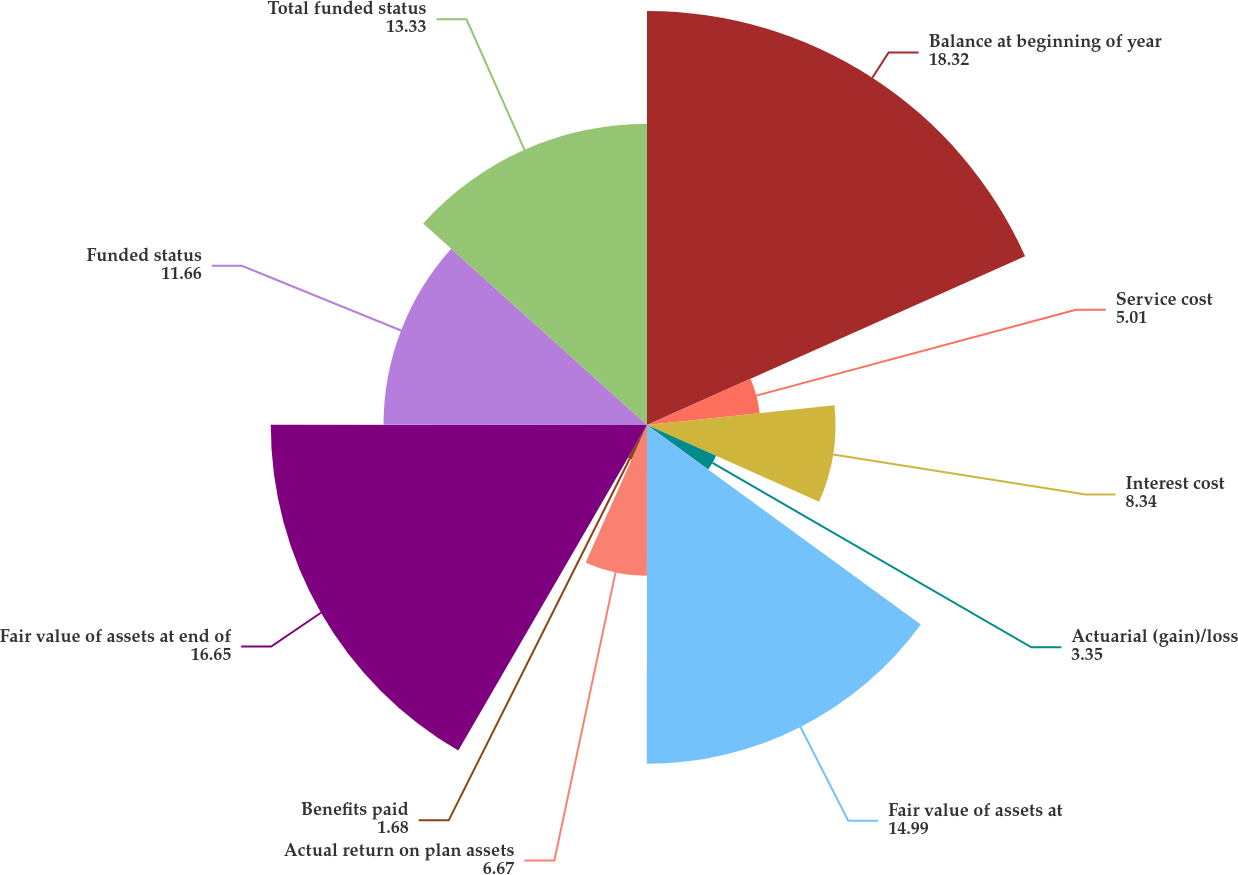Convert chart. <chart><loc_0><loc_0><loc_500><loc_500><pie_chart><fcel>Balance at beginning of year<fcel>Service cost<fcel>Interest cost<fcel>Actuarial (gain)/loss<fcel>Fair value of assets at<fcel>Actual return on plan assets<fcel>Benefits paid<fcel>Fair value of assets at end of<fcel>Funded status<fcel>Total funded status<nl><fcel>18.32%<fcel>5.01%<fcel>8.34%<fcel>3.35%<fcel>14.99%<fcel>6.67%<fcel>1.68%<fcel>16.65%<fcel>11.66%<fcel>13.33%<nl></chart> 